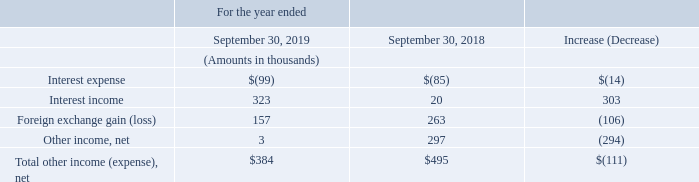Other Income/Expense
The following table details our other income/expenses for the years ended September 30, 2019 and 2018:
The decrease to other income (expenses) for the fiscal year ended September 30, 2019 as compared to the fiscal year ended September 30, 2018 was primarily driven by a decrease in Other income, net of $0.3 mil.
When does the company's fiscal year end? September 30. What is the company's total net income in 2019?
Answer scale should be: thousand. $384. What caused the decrease in income between 2018 and 2019? A decrease in other income. What is the company's percentage change in total other income between 2018 and 2019?
Answer scale should be: percent. - $111/$495 * 1 
Answer: -22.42. What is the company's net interest expense in 2018?
Answer scale should be: thousand. -$85 + 20 
Answer: -65. What percentage of the company's 2019 total other income is the foreign exchange gain?
Answer scale should be: percent. 157/384 * 1 
Answer: 40.89. 